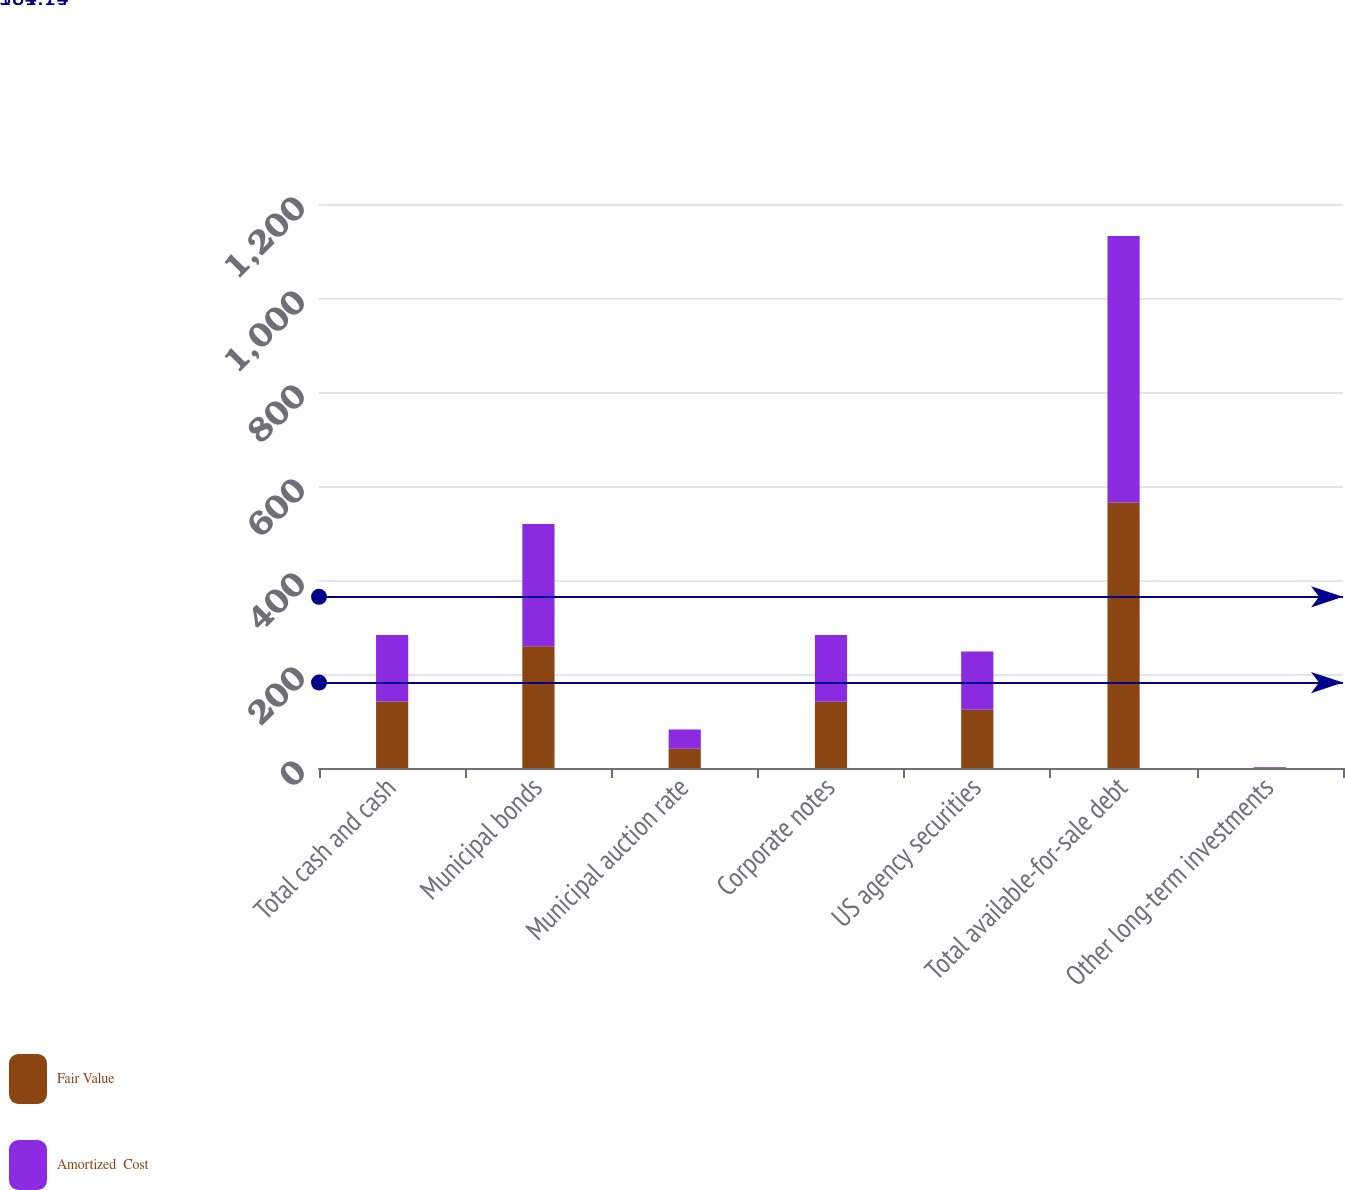Convert chart. <chart><loc_0><loc_0><loc_500><loc_500><stacked_bar_chart><ecel><fcel>Total cash and cash<fcel>Municipal bonds<fcel>Municipal auction rate<fcel>Corporate notes<fcel>US agency securities<fcel>Total available-for-sale debt<fcel>Other long-term investments<nl><fcel>Fair Value<fcel>141.5<fcel>259<fcel>41<fcel>141<fcel>124<fcel>565<fcel>1<nl><fcel>Amortized  Cost<fcel>141.5<fcel>260<fcel>41<fcel>142<fcel>124<fcel>567<fcel>1<nl></chart> 